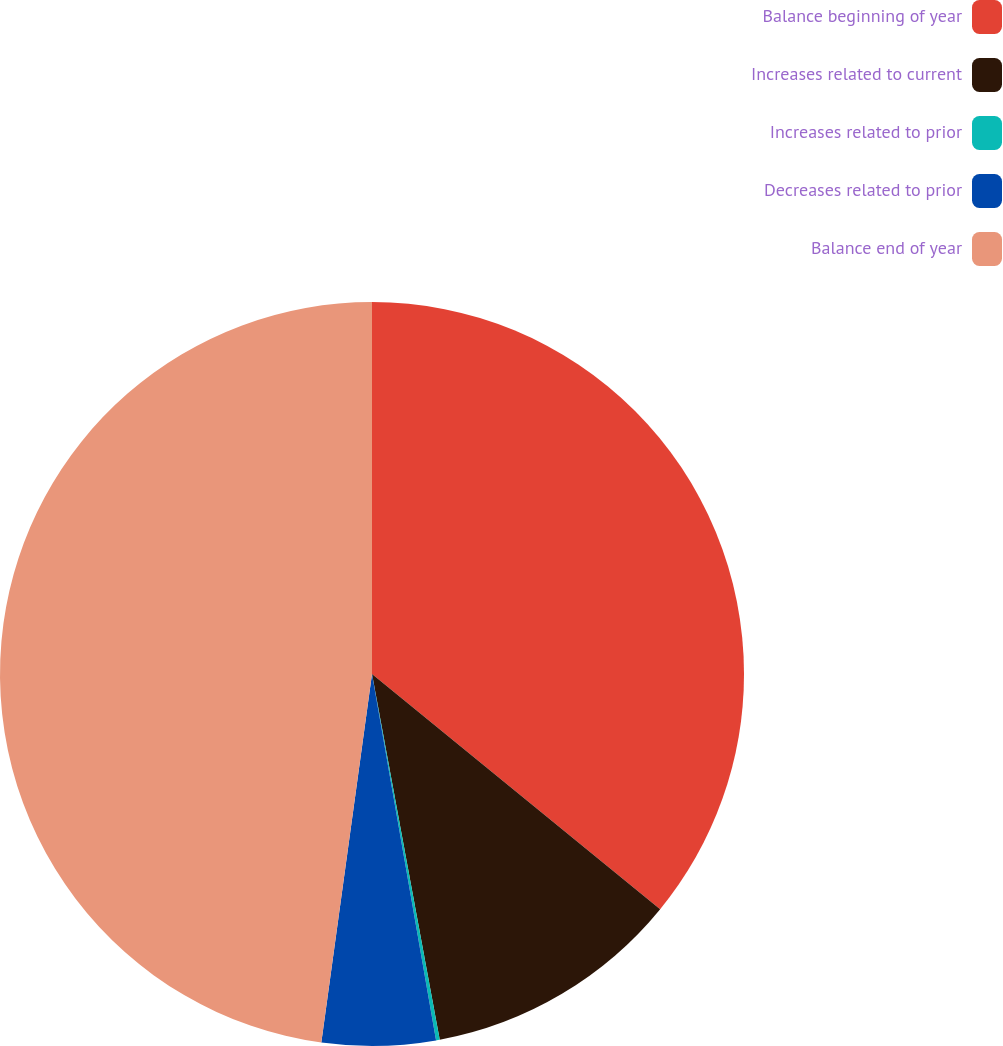Convert chart. <chart><loc_0><loc_0><loc_500><loc_500><pie_chart><fcel>Balance beginning of year<fcel>Increases related to current<fcel>Increases related to prior<fcel>Decreases related to prior<fcel>Balance end of year<nl><fcel>35.9%<fcel>11.19%<fcel>0.16%<fcel>4.93%<fcel>47.83%<nl></chart> 